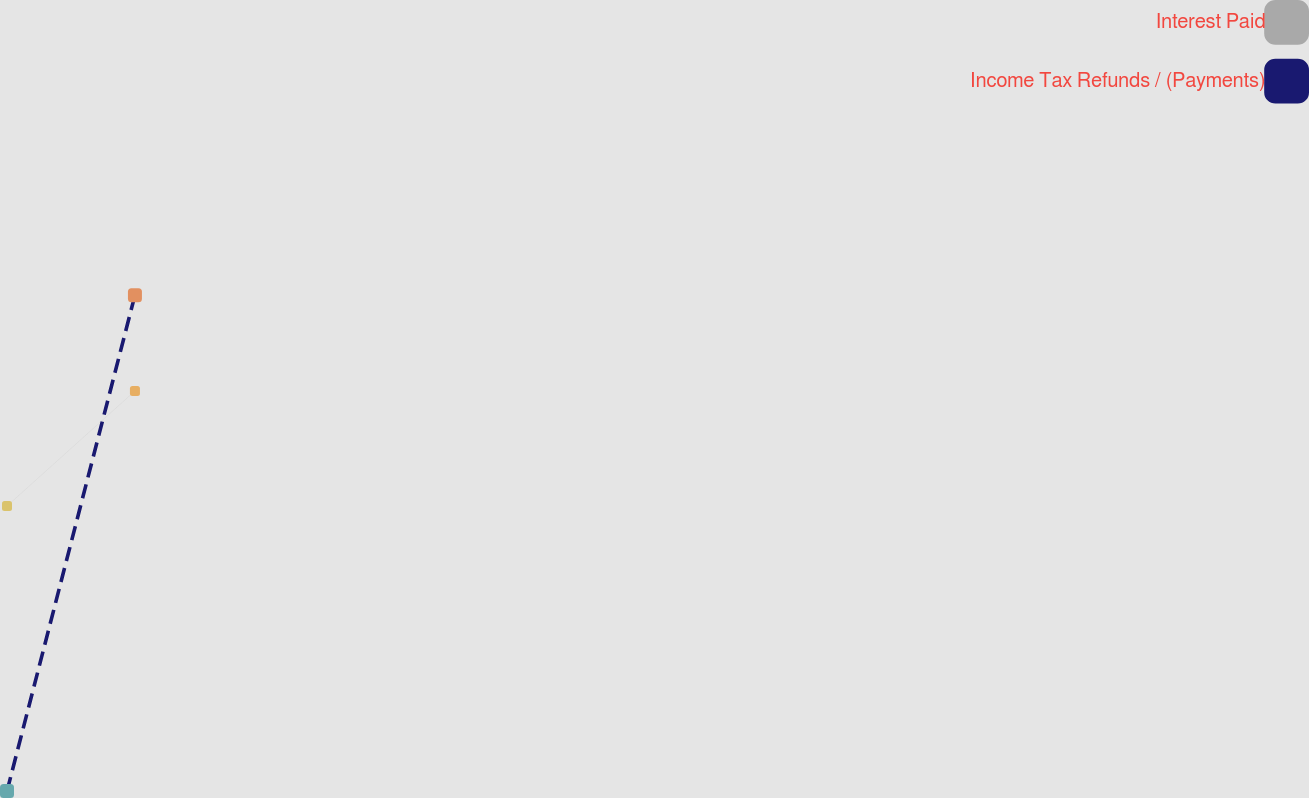<chart> <loc_0><loc_0><loc_500><loc_500><line_chart><ecel><fcel>Interest Paid<fcel>Income Tax Refunds / (Payments)<nl><fcel>2079.67<fcel>293.73<fcel>145.26<nl><fcel>2090.45<fcel>353.66<fcel>403.54<nl><fcel>2187.52<fcel>510.66<fcel>116.56<nl></chart> 